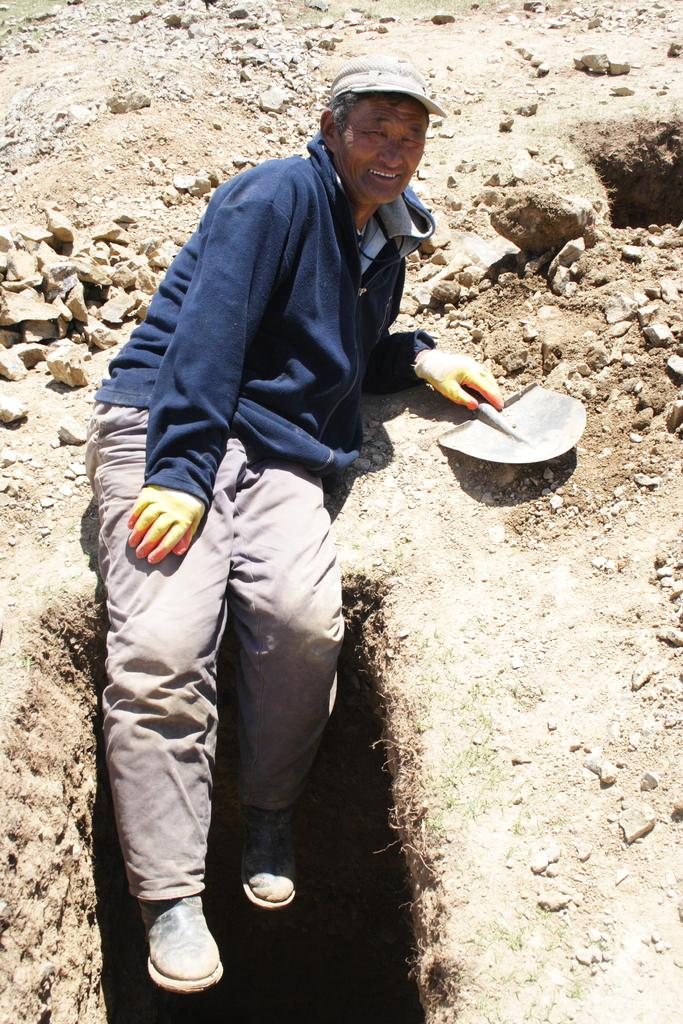Who is present in the image? There is a man in the image. What is the man doing in the image? The man is sitting on the ground. What object is the man holding in the image? The man is holding a shovel. What protective gear is the man wearing in the image? The man is wearing hand gloves. What type of terrain is visible in the image? There are stones and mud on the ground. What type of books can be seen in the library in the image? There is no library present in the image; it features a man sitting on the ground with a shovel and hand gloves. What kind of cast is visible on the man's arm in the image? There is no cast visible on the man's arm in the image; he is wearing hand gloves. 